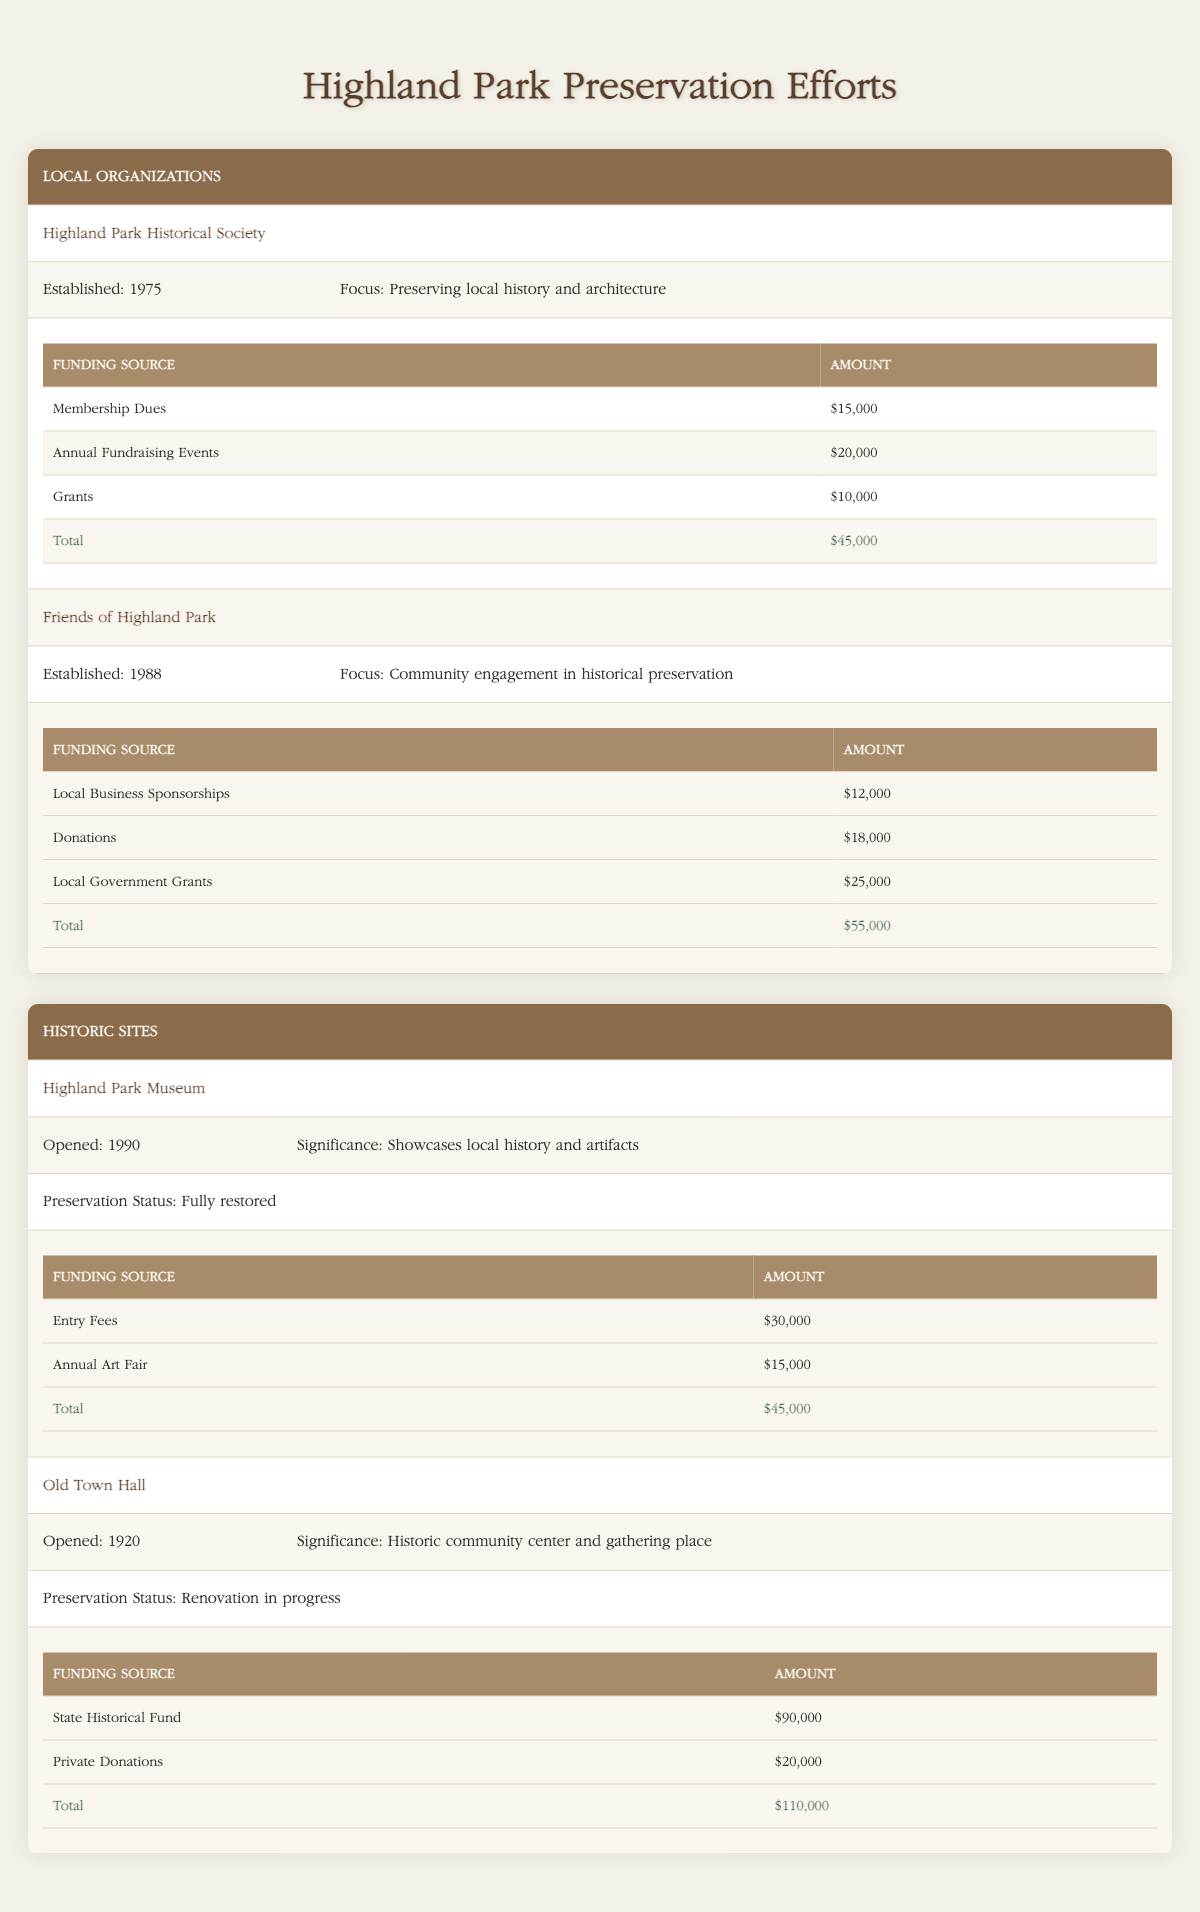What is the total funding for the Highland Park Historical Society? To find the total funding for the Highland Park Historical Society, we need to sum the amounts from its three funding sources: Membership Dues ($15,000), Annual Fundraising Events ($20,000), and Grants ($10,000). So, the total is $15,000 + $20,000 + $10,000 = $45,000.
Answer: $45,000 What is the focus of the Friends of Highland Park? The focus of the Friends of Highland Park is mentioned directly in the table as "Community engagement in historical preservation."
Answer: Community engagement in historical preservation Is the Old Town Hall fully restored? The preservation status of the Old Town Hall is listed as "Renovation in progress," which indicates that it is not fully restored.
Answer: No What is the combined total funding for both historic sites? To get the combined total funding, we need to add together the total funding for each site: for Highland Park Museum, there are Entry Fees ($30,000) and Annual Art Fair ($15,000), totaling $45,000. For Old Town Hall, the State Historical Fund contributes $90,000 and Private Donations contribute $20,000, totaling $110,000. Thus, the combined total is $45,000 + $110,000 = $155,000.
Answer: $155,000 Which organization has higher total funding, Highland Park Historical Society or Friends of Highland Park? The total funding for Highland Park Historical Society is $45,000, while for Friends of Highland Park it is $55,000. Since $55,000 is greater than $45,000, Friends of Highland Park has higher total funding.
Answer: Friends of Highland Park What is the average funding amount for the Friends of Highland Park's funding sources? Friends of Highland Park has three funding sources: Local Business Sponsorships ($12,000), Donations ($18,000), and Local Government Grants ($25,000). To find the average, add these amounts ($12,000 + $18,000 + $25,000 = $55,000) and divide by the number of sources (3). So, the average funding amount is $55,000 / 3 = $18,333.33, approximately $18,333.
Answer: $18,333 How much funding does the Highland Park Museum generate from entry fees? The amount generated from entry fees for the Highland Park Museum is listed as $30,000 directly in the table.
Answer: $30,000 Do both organizations focus on preserving history? Yes, both organizations focus on preserving history, as the Highland Park Historical Society focuses on "Preserving local history and architecture," and Friends of Highland Park emphasizes "Community engagement in historical preservation."
Answer: Yes What is the total funding for all local organizations combined? The total funding for local organizations combines Highland Park Historical Society's $45,000 and Friends of Highland Park's $55,000. We add these amounts: $45,000 + $55,000 = $100,000.
Answer: $100,000 